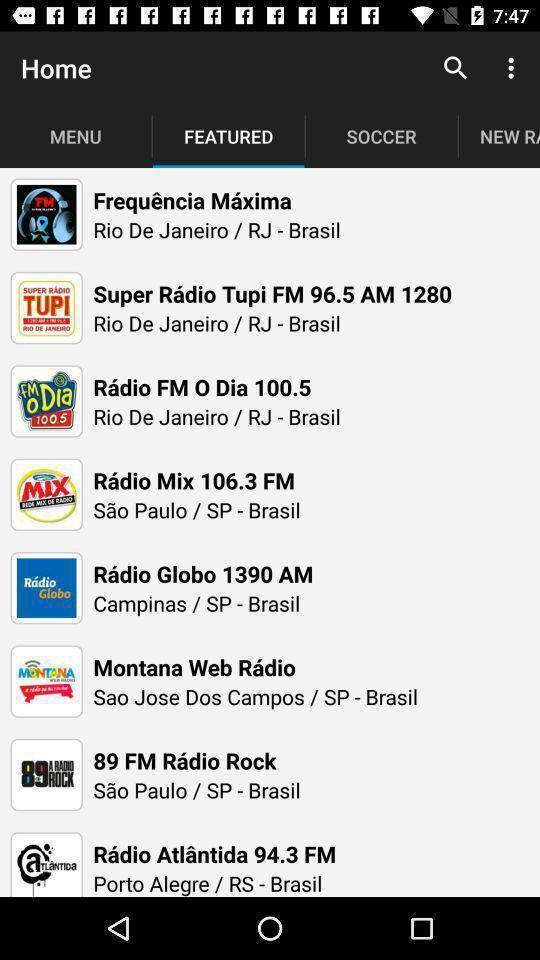Provide a textual representation of this image. Various radio stations displayed. 